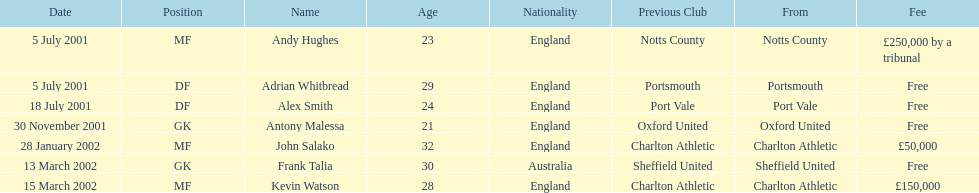Are there at least 2 nationalities on the chart? Yes. 